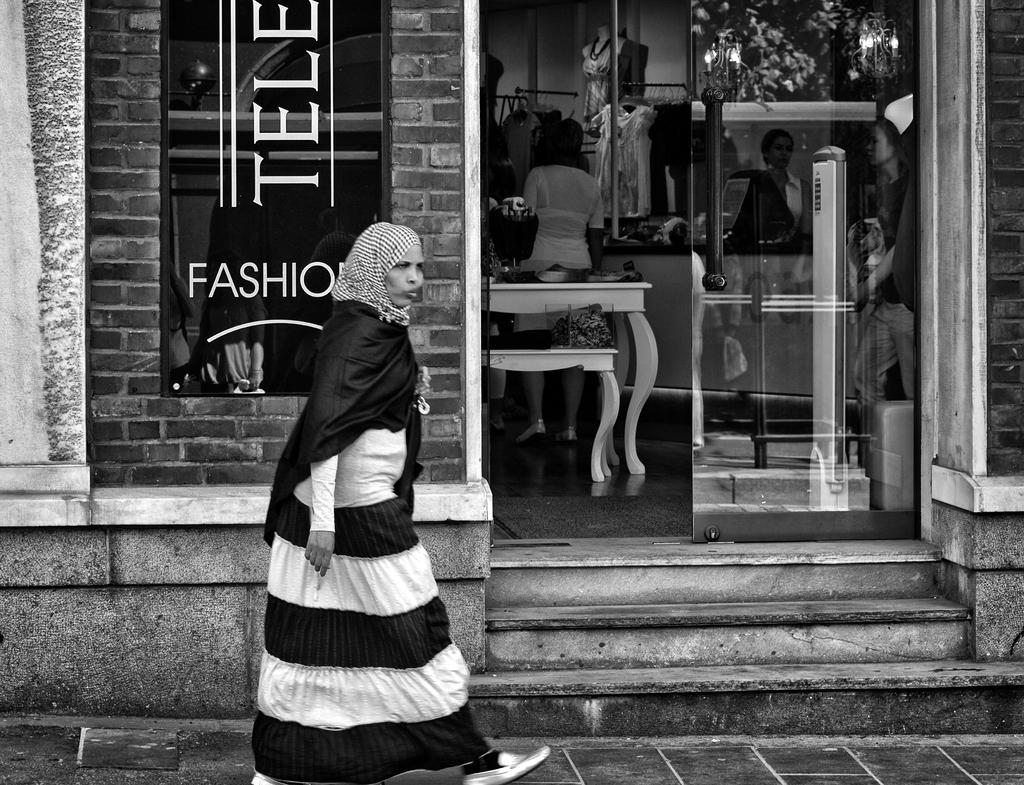What is the man in the image doing? The man in the image is walking. What can be seen in the background of the image? There is a store in the image. What is happening near the store? There are people standing near the store. What is inside the store? There are clothes hanging in the store, and there is a table in the store. What type of drink is the dad holding in the image? There is no dad or drink present in the image. What type of work does the laborer perform in the image? There is no laborer present in the image. 